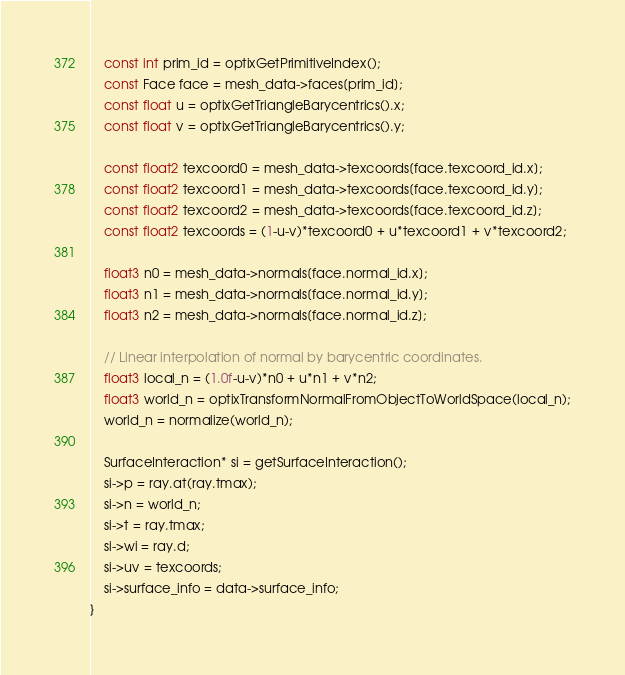Convert code to text. <code><loc_0><loc_0><loc_500><loc_500><_Cuda_>    const int prim_id = optixGetPrimitiveIndex();
    const Face face = mesh_data->faces[prim_id];
    const float u = optixGetTriangleBarycentrics().x;
    const float v = optixGetTriangleBarycentrics().y;

    const float2 texcoord0 = mesh_data->texcoords[face.texcoord_id.x];
    const float2 texcoord1 = mesh_data->texcoords[face.texcoord_id.y];
    const float2 texcoord2 = mesh_data->texcoords[face.texcoord_id.z];
    const float2 texcoords = (1-u-v)*texcoord0 + u*texcoord1 + v*texcoord2;

    float3 n0 = mesh_data->normals[face.normal_id.x];
	float3 n1 = mesh_data->normals[face.normal_id.y];
	float3 n2 = mesh_data->normals[face.normal_id.z];

    // Linear interpolation of normal by barycentric coordinates.
    float3 local_n = (1.0f-u-v)*n0 + u*n1 + v*n2;
    float3 world_n = optixTransformNormalFromObjectToWorldSpace(local_n);
    world_n = normalize(world_n);

    SurfaceInteraction* si = getSurfaceInteraction();
    si->p = ray.at(ray.tmax);
    si->n = world_n;
    si->t = ray.tmax;
    si->wi = ray.d;
    si->uv = texcoords;
    si->surface_info = data->surface_info;
}</code> 